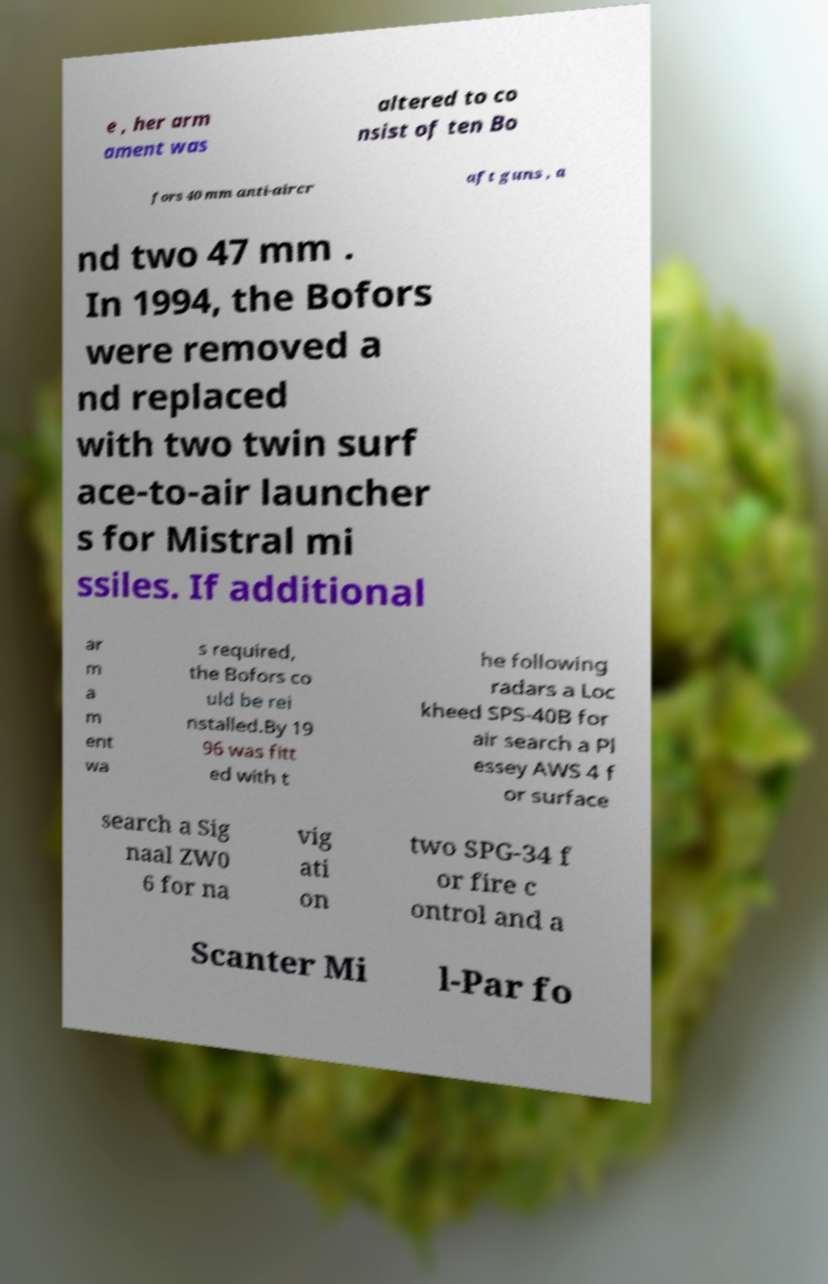What messages or text are displayed in this image? I need them in a readable, typed format. e , her arm ament was altered to co nsist of ten Bo fors 40 mm anti-aircr aft guns , a nd two 47 mm . In 1994, the Bofors were removed a nd replaced with two twin surf ace-to-air launcher s for Mistral mi ssiles. If additional ar m a m ent wa s required, the Bofors co uld be rei nstalled.By 19 96 was fitt ed with t he following radars a Loc kheed SPS-40B for air search a Pl essey AWS 4 f or surface search a Sig naal ZW0 6 for na vig ati on two SPG-34 f or fire c ontrol and a Scanter Mi l-Par fo 